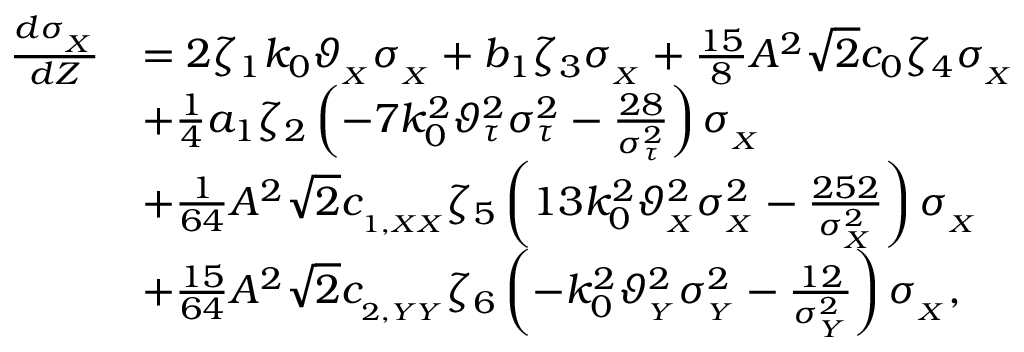<formula> <loc_0><loc_0><loc_500><loc_500>\begin{array} { r l } { \frac { d \sigma _ { _ { X } } } { d Z } } & { = 2 \zeta _ { 1 } k _ { 0 } \vartheta _ { _ { X } } \sigma _ { _ { X } } + b _ { 1 } \zeta _ { 3 } \sigma _ { _ { X } } + \frac { 1 5 } { 8 } A ^ { 2 } \sqrt { 2 } c _ { 0 } \zeta _ { 4 } \sigma _ { _ { X } } } \\ & { + \frac { 1 } { 4 } a _ { 1 } \zeta _ { 2 } \left ( - 7 k _ { 0 } ^ { 2 } \vartheta _ { \tau } ^ { 2 } \sigma _ { \tau } ^ { 2 } - \frac { 2 8 } { \sigma _ { \tau } ^ { 2 } } \right ) \sigma _ { _ { X } } } \\ & { + \frac { 1 } { 6 4 } A ^ { 2 } \sqrt { 2 } c _ { _ { 1 , X X } } \zeta _ { 5 } \left ( 1 3 k _ { 0 } ^ { 2 } \vartheta _ { _ { X } } ^ { 2 } \sigma _ { _ { X } } ^ { 2 } - \frac { 2 5 2 } { \sigma _ { _ { X } } ^ { 2 } } \right ) \sigma _ { _ { X } } } \\ & { + \frac { 1 5 } { 6 4 } A ^ { 2 } \sqrt { 2 } c _ { _ { 2 , Y Y } } \zeta _ { 6 } \left ( - k _ { 0 } ^ { 2 } \vartheta _ { _ { Y } } ^ { 2 } \sigma _ { _ { Y } } ^ { 2 } - \frac { 1 2 } { \sigma _ { _ { Y } } ^ { 2 } } \right ) \sigma _ { _ { X } } , } \end{array}</formula> 